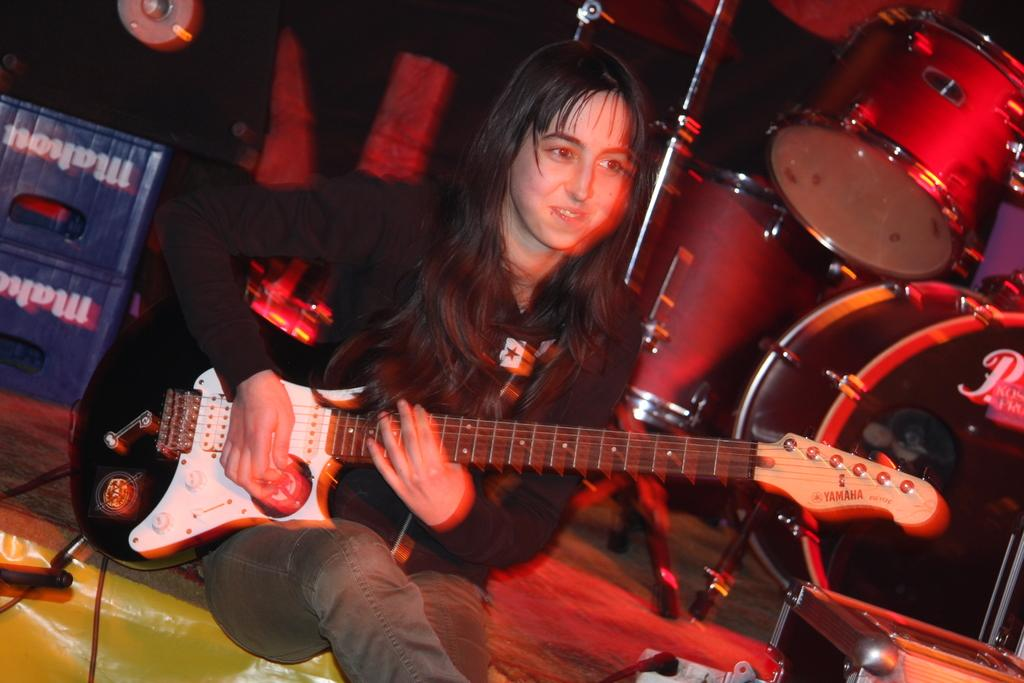Who is the main subject in the image? There is a woman in the image. What is the woman doing in the image? The woman is sitting on a chair and playing a guitar. What else can be seen in the image besides the woman? There are musical instruments in the background of the image. What type of pie is the woman eating in the image? There is no pie present in the image; the woman is playing a guitar. How many grapes can be seen on the chair the woman is sitting on? There are no grapes visible in the image; the woman is sitting on a chair while playing a guitar. 